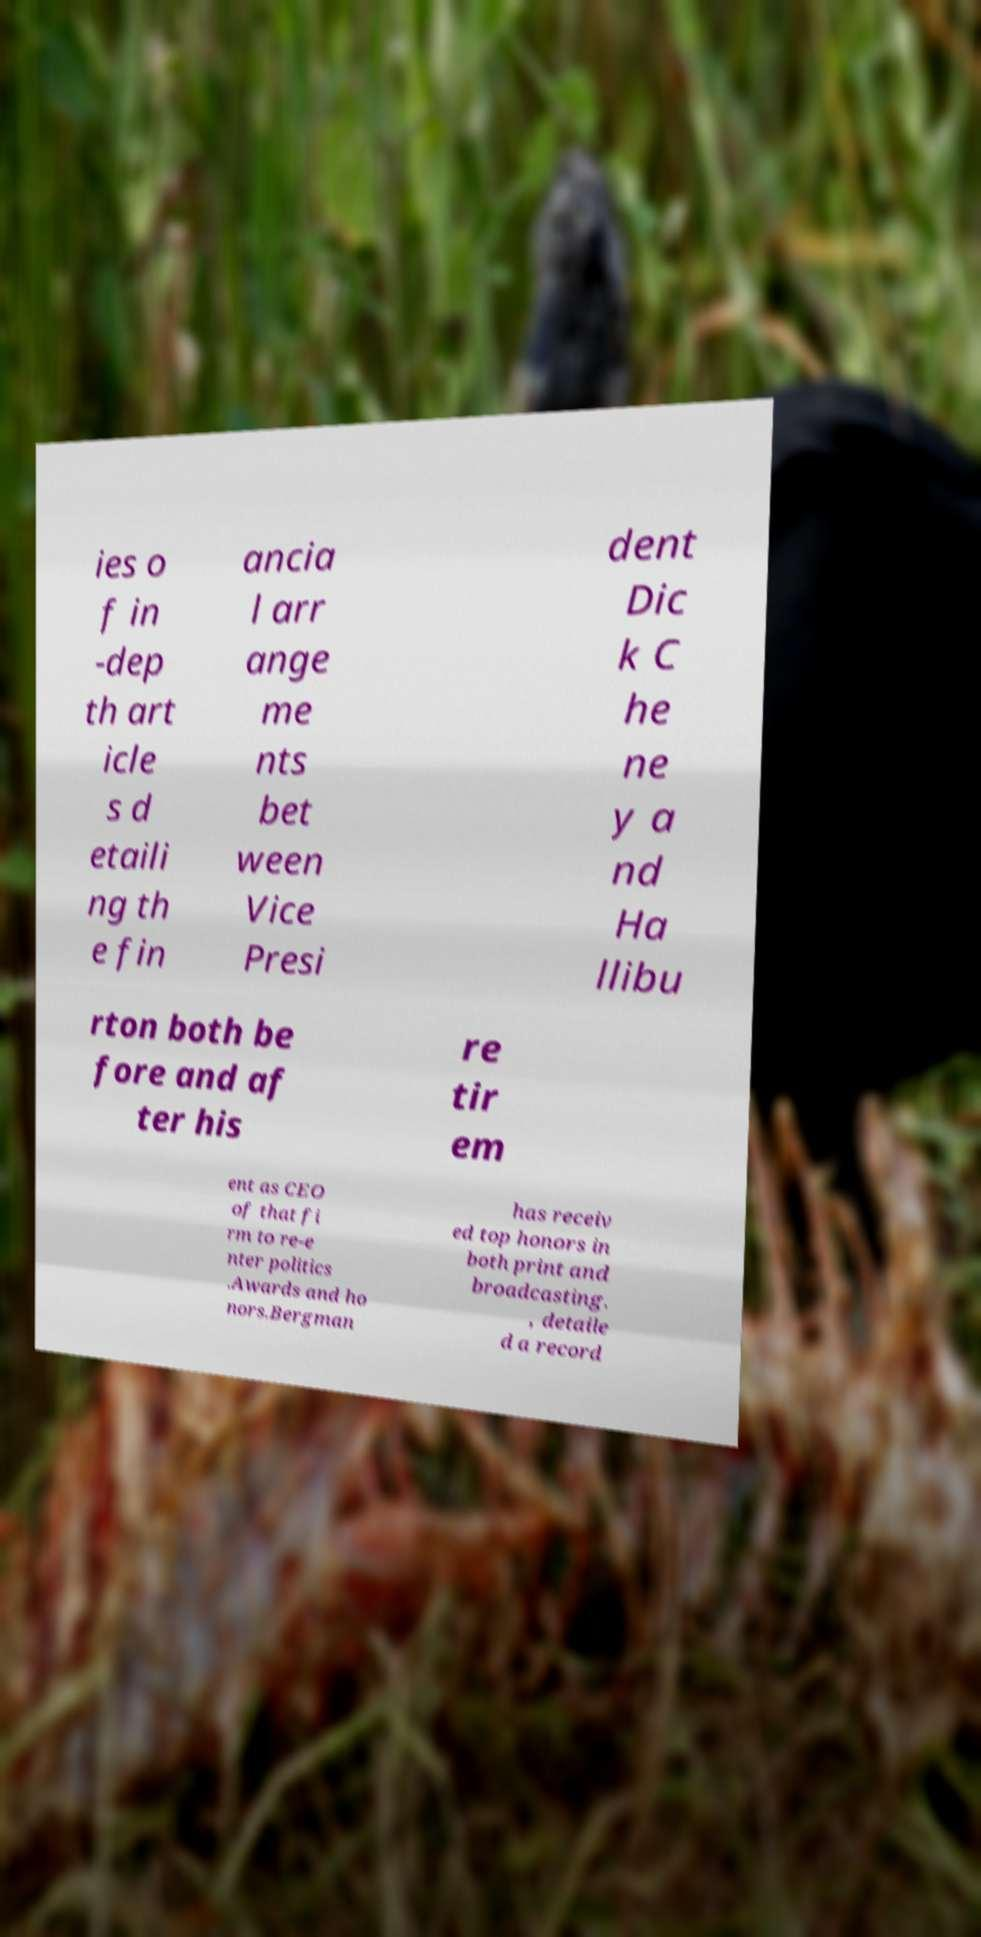There's text embedded in this image that I need extracted. Can you transcribe it verbatim? ies o f in -dep th art icle s d etaili ng th e fin ancia l arr ange me nts bet ween Vice Presi dent Dic k C he ne y a nd Ha llibu rton both be fore and af ter his re tir em ent as CEO of that fi rm to re-e nter politics .Awards and ho nors.Bergman has receiv ed top honors in both print and broadcasting. , detaile d a record 